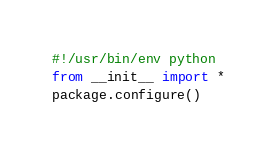<code> <loc_0><loc_0><loc_500><loc_500><_Python_>#!/usr/bin/env python
from __init__ import *
package.configure()
</code> 